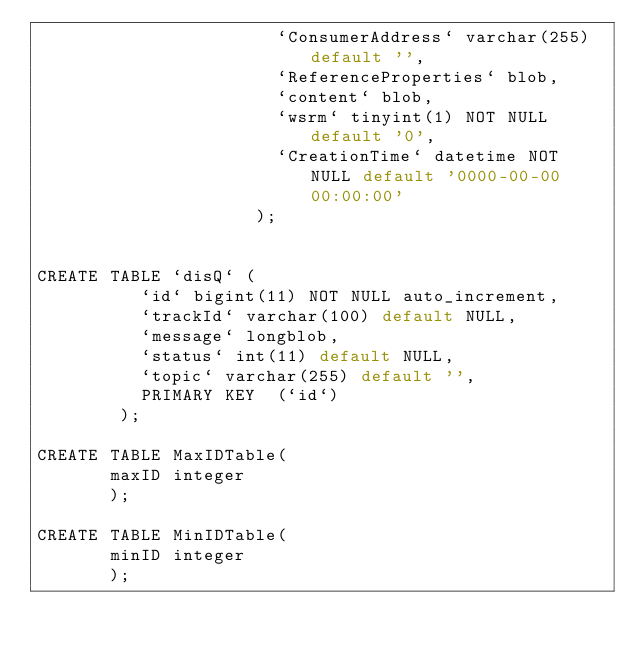<code> <loc_0><loc_0><loc_500><loc_500><_SQL_>                       `ConsumerAddress` varchar(255) default '',
                       `ReferenceProperties` blob,
                       `content` blob,
                       `wsrm` tinyint(1) NOT NULL default '0',
                       `CreationTime` datetime NOT NULL default '0000-00-00 00:00:00'
                     );


CREATE TABLE `disQ` (
          `id` bigint(11) NOT NULL auto_increment,
          `trackId` varchar(100) default NULL,
          `message` longblob,
          `status` int(11) default NULL,
          `topic` varchar(255) default '',
          PRIMARY KEY  (`id`)
        );

CREATE TABLE MaxIDTable(
       maxID integer
       );

CREATE TABLE MinIDTable(
       minID integer
       );

</code> 